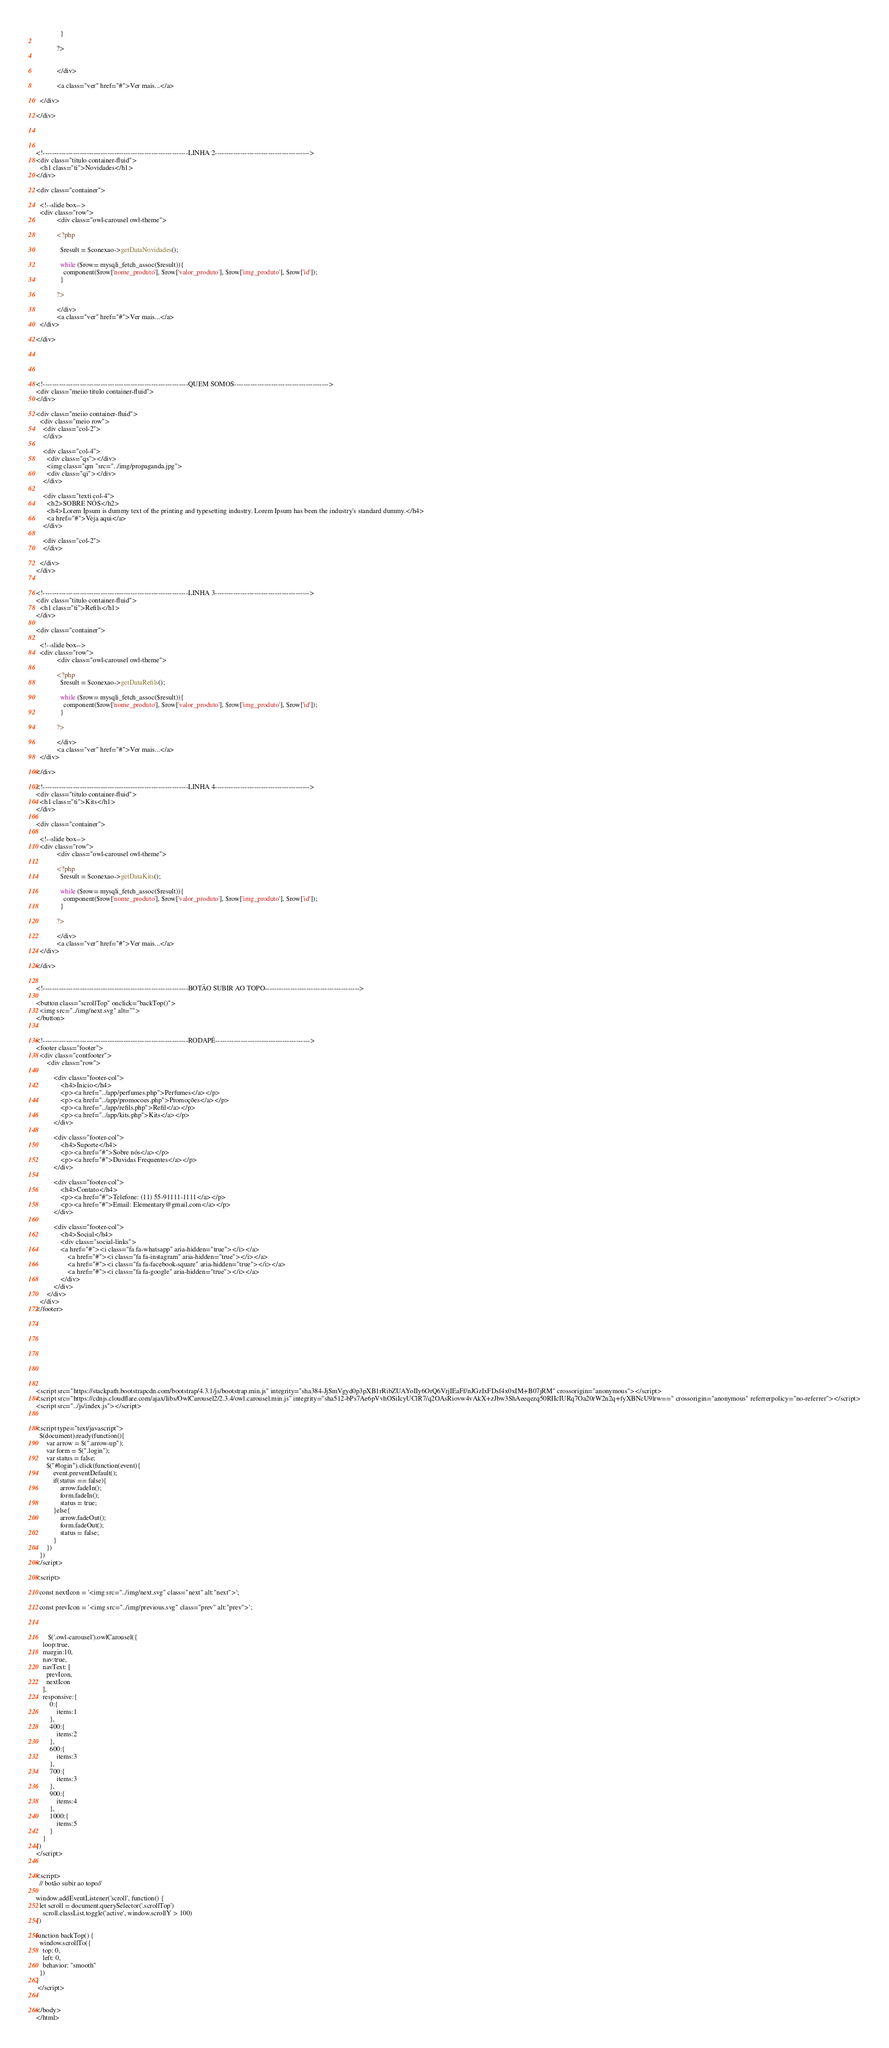Convert code to text. <code><loc_0><loc_0><loc_500><loc_500><_PHP_>              }

            ?>
               
               
            </div>

            <a class="ver" href="#">Ver mais...</a>

  </div>

</div>




<!---------------------------------------------------------------LINHA 2----------------------------------------->
<div class="titulo container-fluid">
  <h1 class="ti">Novidades</h1>
</div>

<div class="container">

  <!--slide box-->
  <div class="row">
            <div class="owl-carousel owl-theme">

            <?php
              
              $result = $conexao->getDataNovidades();

              while ($row= mysqli_fetch_assoc($result)){
                component($row['nome_produto'], $row['valor_produto'], $row['img_produto'], $row['id']);
              }

            ?>
               
            </div>
            <a class="ver" href="#">Ver mais...</a>
  </div>

</div>





<!---------------------------------------------------------------QUEM SOMOS----------------------------------------->
<div class="meiio titulo container-fluid">
</div>

<div class="meiio container-fluid">
  <div class="meio row">
    <div class="col-2">
    </div>

    <div class="col-4">
      <div class="qs"></div>
      <img class="qm "src="../img/propaganda.jpg">
      <div class="qi"></div>
    </div>

    <div class="texti col-4">
      <h2>SOBRE NÓS</h2>
      <h4>Lorem Ipsum is dummy text of the printing and typesetting industry. Lorem Ipsum has been the industry's standard dummy.</h4>
      <a href="#">Veja aqui</a>
    </div>  

    <div class="col-2">
    </div>

  </div>
</div>


<!---------------------------------------------------------------LINHA 3----------------------------------------->
<div class="titulo container-fluid">
  <h1 class="ti">Refils</h1>
</div>

<div class="container">

  <!--slide box-->
  <div class="row">
            <div class="owl-carousel owl-theme">

            <?php
              $result = $conexao->getDataRefils();

              while ($row= mysqli_fetch_assoc($result)){
                component($row['nome_produto'], $row['valor_produto'], $row['img_produto'], $row['id']);
              }

            ?>
               
            </div>
            <a class="ver" href="#">Ver mais...</a>
  </div>

</div>

<!---------------------------------------------------------------LINHA 4----------------------------------------->
<div class="titulo container-fluid">
  <h1 class="ti">Kits</h1>
</div>

<div class="container">

  <!--slide box-->
  <div class="row">
            <div class="owl-carousel owl-theme">

            <?php
              $result = $conexao->getDataKits();

              while ($row= mysqli_fetch_assoc($result)){
                component($row['nome_produto'], $row['valor_produto'], $row['img_produto'], $row['id']);
              }

            ?>
               
            </div>
            <a class="ver" href="#">Ver mais...</a>
  </div>

</div>


<!---------------------------------------------------------------BOTÃO SUBIR AO TOPO----------------------------------------->

<button class="scrollTop" onclick="backTop()">
  <img src="../img/next.svg" alt="">
</button>


<!---------------------------------------------------------------RODAPÉ----------------------------------------->
<footer class="footer">
  <div class="contfooter">
      <div class="row">

          <div class="footer-col">
              <h4>Inicio</h4>
              <p><a href="../app/perfumes.php">Perfumes</a></p>
              <p><a href="../app/promocoes.php">Promoções</a></p>
              <p><a href="../app/refils.php">Refil</a></p>
              <p><a href="../app/kits.php">Kits</a></p>
          </div>

          <div class="footer-col">
              <h4>Suporte</h4>
              <p><a href="#">Sobre nós</a></p>
              <p><a href="#">Duvidas Frequentes</a></p>
          </div>

          <div class="footer-col">
              <h4>Contato</h4>
              <p><a href="#">Telefone: (11) 55-91111-1111</a></p>
              <p><a href="#">Email: Elementary@gmail.com</a></p>
          </div>
          
          <div class="footer-col">
              <h4>Social</h4>
              <div class="social-links">
              <a href="#"><i class="fa fa-whatsapp" aria-hidden="true"></i></a>
                  <a href="#"><i class="fa fa-instagram" aria-hidden="true"></i></a>
                  <a href="#"><i class="fa fa-facebook-square" aria-hidden="true"></i></a>
                  <a href="#"><i class="fa fa-google" aria-hidden="true"></i></a>
              </div>
          </div>
      </div>
  </div>
</footer>










<script src="https://stackpath.bootstrapcdn.com/bootstrap/4.3.1/js/bootstrap.min.js" integrity="sha384-JjSmVgyd0p3pXB1rRibZUAYoIIy6OrQ6VrjIEaFf/nJGzIxFDsf4x0xIM+B07jRM" crossorigin="anonymous"></script>
<script src="https://cdnjs.cloudflare.com/ajax/libs/OwlCarousel2/2.3.4/owl.carousel.min.js" integrity="sha512-bPs7Ae6pVvhOSiIcyUClR7/q2OAsRiovw4vAkX+zJbw3ShAeeqezq50RIIcIURq7Oa20rW2n2q+fyXBNcU9lrw==" crossorigin="anonymous" referrerpolicy="no-referrer"></script>
<script src="../js/index.js"></script>


<script type="text/javascript">
  $(document).ready(function(){
      var arrow = $(".arrow-up");
      var form = $(".login");
      var status = false;
      $("#login").click(function(event){
          event.preventDefault();
          if(status == false){
              arrow.fadeIn();
              form.fadeIn();
              status = true;
          }else{
              arrow.fadeOut();
              form.fadeOut();
              status = false;
          }
      })
  })
</script>

<script>

  const nextIcon = '<img src="../img/next.svg" class="next" alt:"next">';
  
  const prevIcon = '<img src="../img/previous.svg" class="prev" alt:"prev">';



       $('.owl-carousel').owlCarousel({
    loop:true,
    margin:10,
    nav:true, 
    navText: [
      prevIcon,
      nextIcon
    ],
    responsive:{
        0:{
            items:1
        },
        400:{
            items:2
        },
        600:{
            items:3
        },
        700:{
            items:3
        },
        900:{
            items:4
        },
        1000:{
            items:5
        }
    }
})
</script>


<script>
  // botão subir ao topo//

window.addEventListener('scroll', function() {
  let scroll = document.querySelector('.scrollTop')
    scroll.classList.toggle('active', window.scrollY > 100)
})

function backTop() {
  window.scrollTo({
    top: 0,
    left: 0,
    behavior: "smooth"
  })
}
 </script>


</body>
</html></code> 